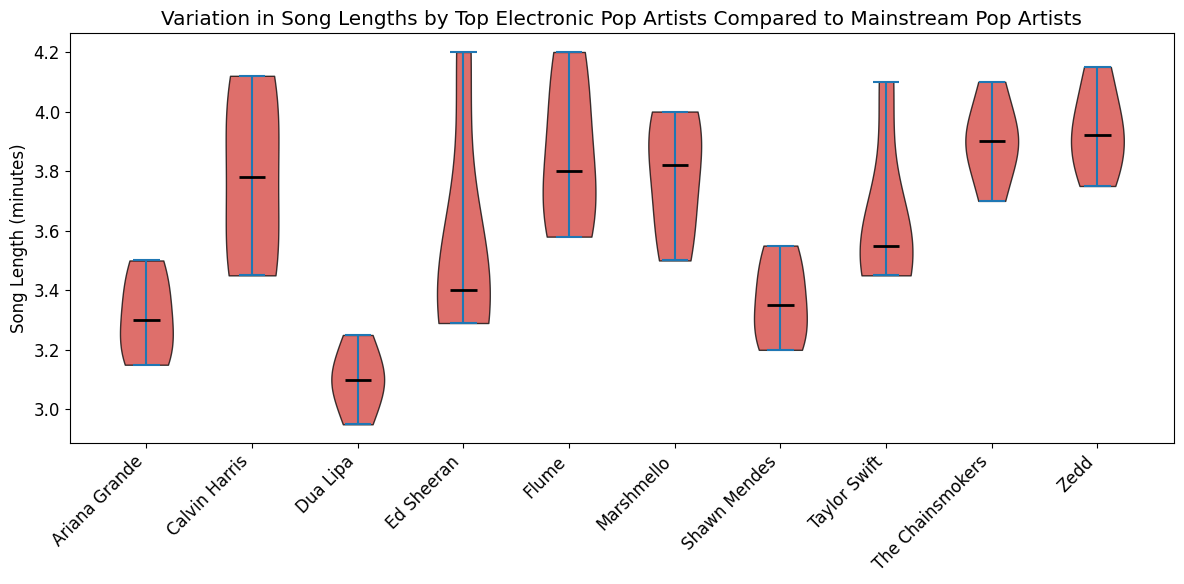Which artist has the highest median song length? Examine the position of the black line representing the median value in the figure. The artist with the highest median line will have the highest median song length.
Answer: Flume How do the median song lengths of Calvin Harris and Zedd compare? Look at the median lines for both Calvin Harris and Zedd. Compare their positions to determine which is higher.
Answer: Calvin Harris has a slightly higher median What's the range of song lengths for The Chainsmokers? Identify the highest and lowest points of the violin plot for The Chainsmokers. Subtract the lowest value from the highest value to calculate the range.
Answer: 3.70 to 4.10 minutes Which mainstream pop artist has the widest range of song lengths? Compare the width (spread from top to bottom) of all the mainstream pop artists' violin plots. The artist with the broadest range visually shows the widest range of song lengths.
Answer: Ed Sheeran On average, are electronic pop artists' song lengths longer than mainstream pop artists' song lengths? Visually inspect the overall height and median positions of the two groups of artists. Electronic pop artists generally have song lengths centered around 3.8 to 4.0 minutes, while mainstream pop artists' song lengths center around 3.2 to 3.6 minutes.
Answer: Yes Which artist's song lengths are closest to 4 minutes frequently? Look for the artists whose violin plots show a peak near the 4-minute mark. Focus on those with the thickest section around this point.
Answer: Zedd and Marshmello Compare the variation in song lengths between Calvin Harris and Taylor Swift. Who has a narrower range? Look at the spread of the violin plot for both artists. Calvin Harris's violin plot is more condensed compared to Taylor Swift's wider spread.
Answer: Calvin Harris Which artists have song lengths with notable outliers? Outliers typically appear as points or anomalies outside the main bulk of the violin plot. Examine plots visually for such characteristics.
Answer: Taylor Swift and Ed Sheeran What is the median song length for Marshmello? Find the position of the black median line within the violin plot for Marshmello. The middle line often represents the median value.
Answer: Approximately 3.82 minutes 